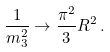Convert formula to latex. <formula><loc_0><loc_0><loc_500><loc_500>\frac { 1 } { m _ { 3 } ^ { 2 } } \rightarrow \frac { \pi ^ { 2 } } { 3 } R ^ { 2 } \, .</formula> 